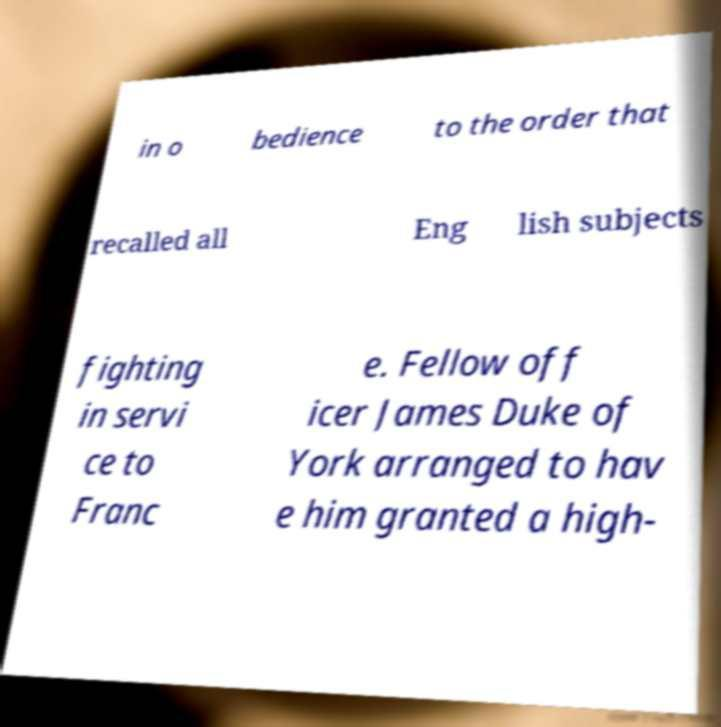Please read and relay the text visible in this image. What does it say? in o bedience to the order that recalled all Eng lish subjects fighting in servi ce to Franc e. Fellow off icer James Duke of York arranged to hav e him granted a high- 